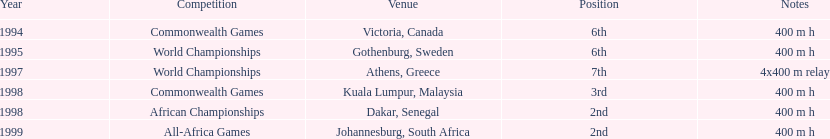Excluding 1999, when did ken harnden come in second place? 1998. 